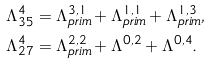Convert formula to latex. <formula><loc_0><loc_0><loc_500><loc_500>\Lambda _ { 3 5 } ^ { 4 } & = \Lambda _ { p r i m } ^ { 3 , 1 } + \Lambda _ { p r i m } ^ { 1 , 1 } + \Lambda _ { p r i m } ^ { 1 , 3 } , \\ \Lambda _ { 2 7 } ^ { 4 } & = \Lambda _ { p r i m } ^ { 2 , 2 } + \Lambda ^ { 0 , 2 } + \Lambda ^ { 0 , 4 } .</formula> 